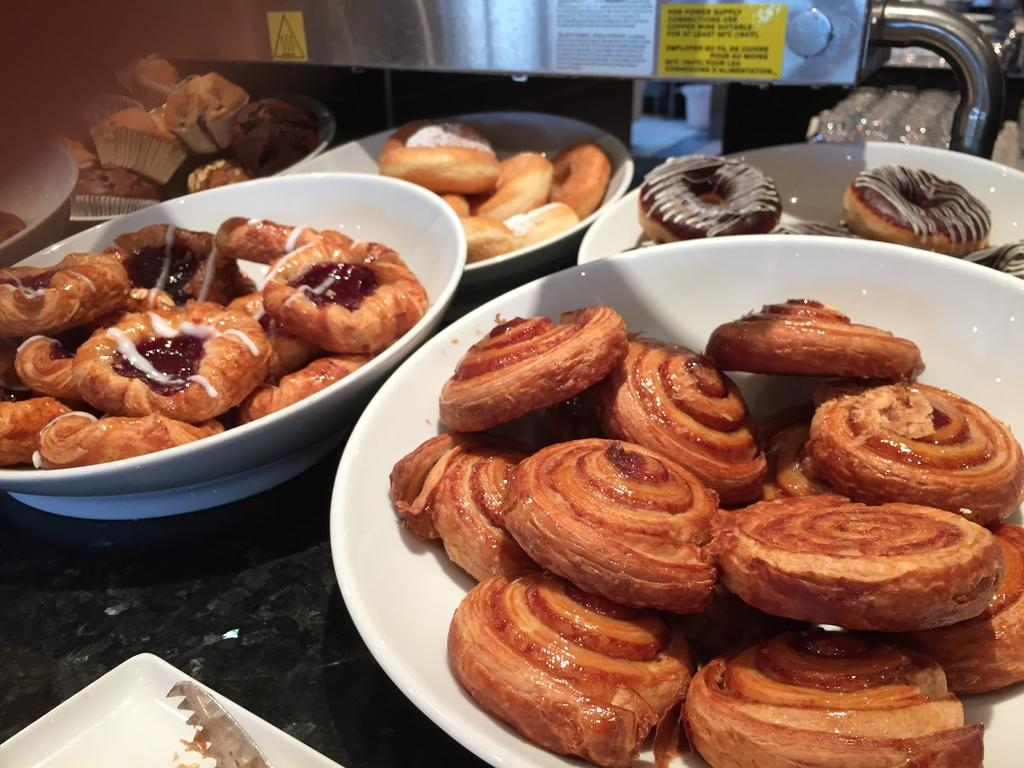What type of containers are present in the image? There are bowls in the image. What type of food items can be seen in the image? There are cupcakes and doughnuts in the image. What type of glue is used to hold the cupcakes together in the image? There is no glue present in the image, and the cupcakes are not held together. 